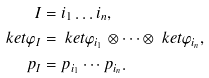Convert formula to latex. <formula><loc_0><loc_0><loc_500><loc_500>I & = i _ { 1 } \dots i _ { n } , \\ \ k e t { \varphi _ { I } } & = \ k e t { \varphi _ { i _ { 1 } } } \otimes \cdots \otimes \ k e t { \varphi _ { i _ { n } } } , \\ p _ { I } & = p _ { i _ { 1 } } \cdots p _ { i _ { n } } .</formula> 